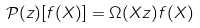<formula> <loc_0><loc_0><loc_500><loc_500>\mathcal { P } ( z ) [ f ( X ) ] = \Omega ( X z ) f ( X )</formula> 